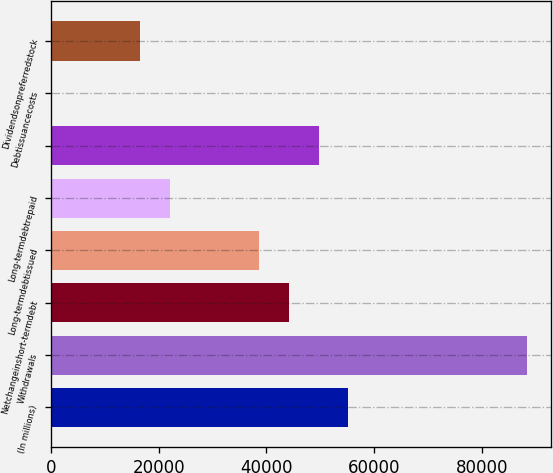<chart> <loc_0><loc_0><loc_500><loc_500><bar_chart><fcel>(In millions)<fcel>Withdrawals<fcel>Netchangeinshort-termdebt<fcel>Long-termdebtissued<fcel>Long-termdebtrepaid<fcel>Unnamed: 5<fcel>Debtissuancecosts<fcel>Dividendsonpreferredstock<nl><fcel>55256<fcel>88401.2<fcel>44207.6<fcel>38683.4<fcel>22110.8<fcel>49731.8<fcel>14<fcel>16586.6<nl></chart> 